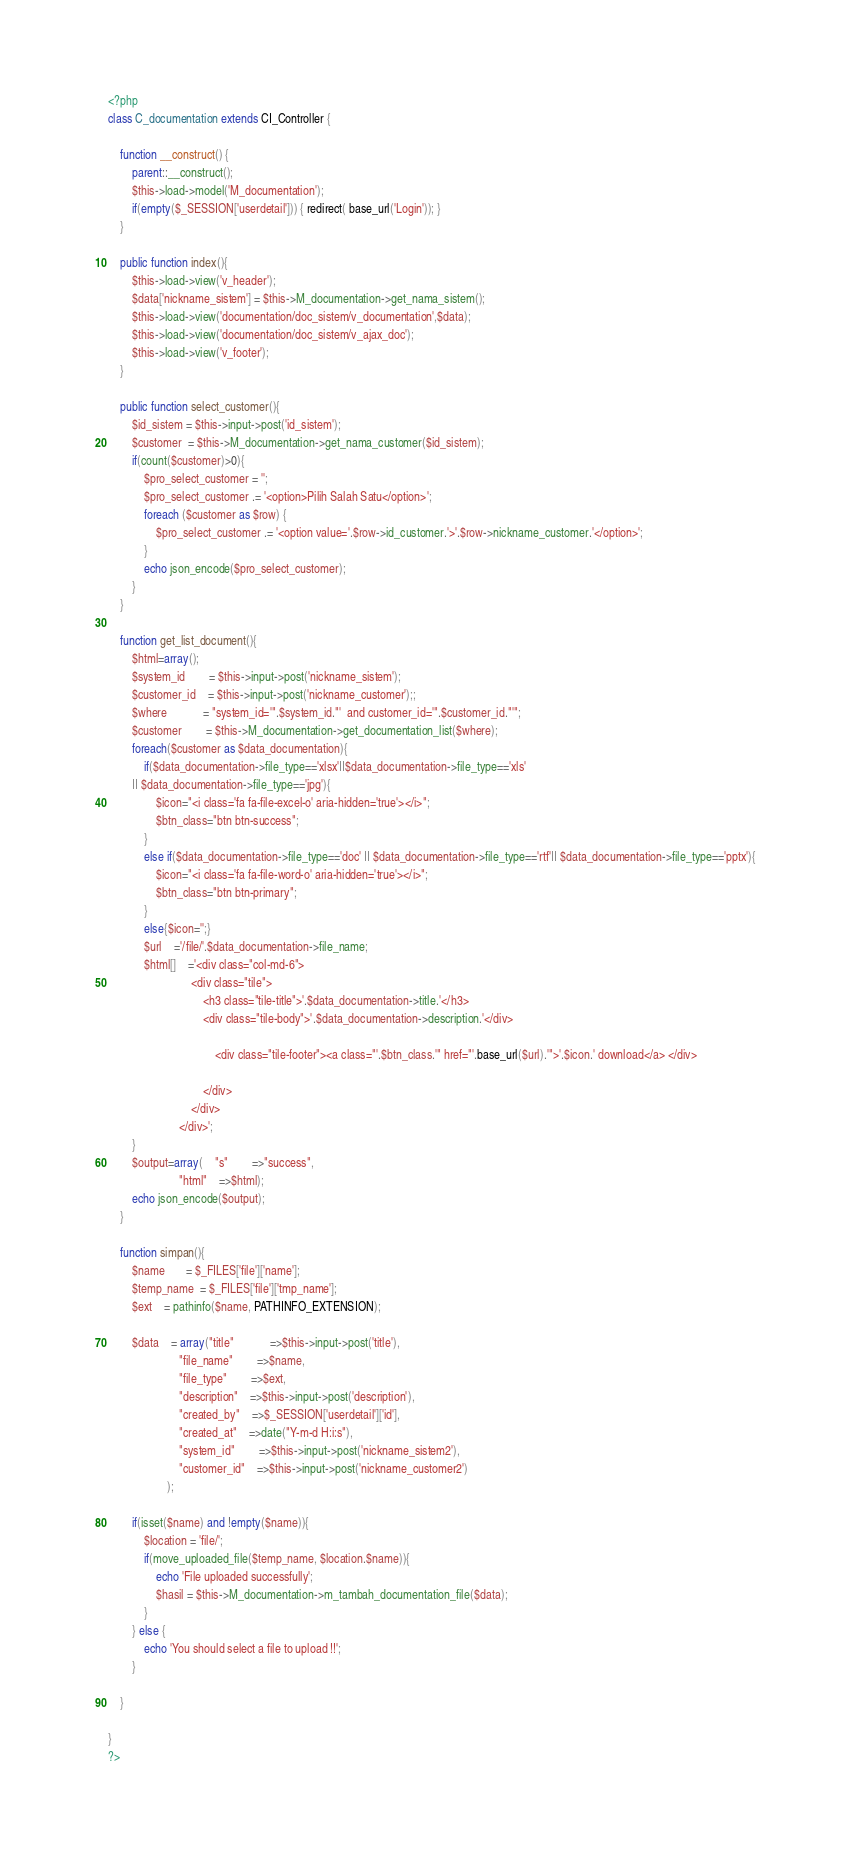<code> <loc_0><loc_0><loc_500><loc_500><_PHP_><?php
class C_documentation extends CI_Controller {

    function __construct() {
		parent::__construct();
		$this->load->model('M_documentation');	
	    if(empty($_SESSION['userdetail'])) { redirect( base_url('Login')); }
	}

	public function index(){
		$this->load->view('v_header');
		$data['nickname_sistem'] = $this->M_documentation->get_nama_sistem();
		$this->load->view('documentation/doc_sistem/v_documentation',$data);
		$this->load->view('documentation/doc_sistem/v_ajax_doc');
		$this->load->view('v_footer');
	}

	public function select_customer(){ 
		$id_sistem = $this->input->post('id_sistem');
		$customer  = $this->M_documentation->get_nama_customer($id_sistem);
		if(count($customer)>0){
			$pro_select_customer = '';
			$pro_select_customer .= '<option>Pilih Salah Satu</option>';
			foreach ($customer as $row) {
				$pro_select_customer .= '<option value='.$row->id_customer.'>'.$row->nickname_customer.'</option>';
			}
			echo json_encode($pro_select_customer);
		}
	}

	function get_list_document(){
		$html=array();
		$system_id		= $this->input->post('nickname_sistem');
		$customer_id	= $this->input->post('nickname_customer');;
		$where			= "system_id='".$system_id."'  and customer_id='".$customer_id."'";
		$customer  		= $this->M_documentation->get_documentation_list($where);
		foreach($customer as $data_documentation){
			if($data_documentation->file_type=='xlsx'||$data_documentation->file_type=='xls'
		|| $data_documentation->file_type=='jpg'){
				$icon="<i class='fa fa-file-excel-o' aria-hidden='true'></i>";
				$btn_class="btn btn-success";
			}
			else if($data_documentation->file_type=='doc' || $data_documentation->file_type=='rtf'|| $data_documentation->file_type=='pptx'){
				$icon="<i class='fa fa-file-word-o' aria-hidden='true'></i>";
				$btn_class="btn btn-primary";
			}
			else{$icon='';}
			$url	='/file/'.$data_documentation->file_name;			
			$html[]	='<div class="col-md-6">
							<div class="tile">
								<h3 class="tile-title">'.$data_documentation->title.'</h3>
								<div class="tile-body">'.$data_documentation->description.'</div>
								 
									<div class="tile-footer"><a class="'.$btn_class.'" href="'.base_url($url).'">'.$icon.' download</a> </div>
									
								</div>
							</div>                
						</div>';
		}
		$output=array(	"s"		=>"success",
						"html"	=>$html);
		echo json_encode($output);
	}
	
	function simpan(){		
		$name       = $_FILES['file']['name'];  
		$temp_name  = $_FILES['file']['tmp_name']; 
		$ext 	= pathinfo($name, PATHINFO_EXTENSION);
		
		$data	= array("title"			=>$this->input->post('title'),
						"file_name"		=>$name,
						"file_type"		=>$ext,
						"description"	=>$this->input->post('description'),
						"created_by"	=>$_SESSION['userdetail']['id'],
						"created_at"	=>date("Y-m-d H:i:s"),
						"system_id"		=>$this->input->post('nickname_sistem2'),
						"customer_id"	=>$this->input->post('nickname_customer2')
					);

		if(isset($name) and !empty($name)){
			$location = 'file/';      
			if(move_uploaded_file($temp_name, $location.$name)){
				echo 'File uploaded successfully';
				$hasil = $this->M_documentation->m_tambah_documentation_file($data);
			}
		} else {
			echo 'You should select a file to upload !!';
		}
		
	}

}
?></code> 